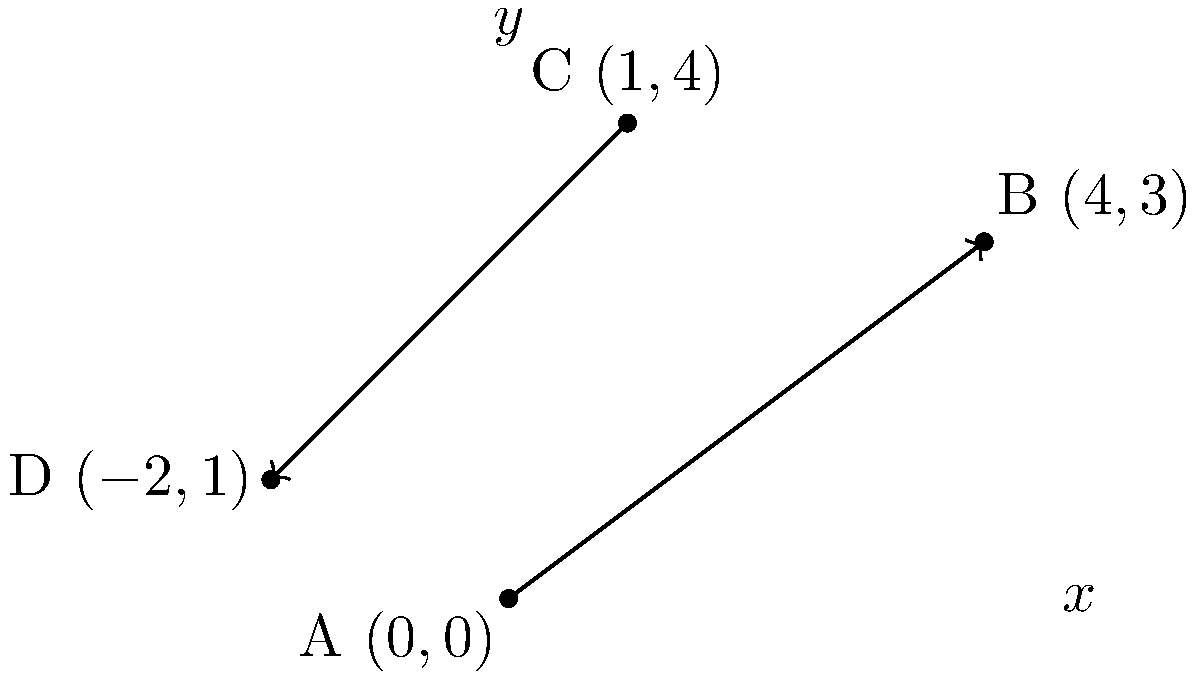In the coordinate plane shown above, two lines intersect. Line 1 passes through points A(0,0) and B(4,3), while Line 2 passes through points C(1,4) and D(-2,1). What is the measure of the acute angle formed by the intersection of these two lines, rounded to the nearest degree? To find the angle between two intersecting lines, we can follow these steps:

1. Calculate the slopes of both lines:

   For Line 1 (AB): $m_1 = \frac{y_B - y_A}{x_B - x_A} = \frac{3 - 0}{4 - 0} = \frac{3}{4}$

   For Line 2 (CD): $m_2 = \frac{y_C - y_D}{x_C - x_D} = \frac{4 - 1}{1 - (-2)} = \frac{3}{3} = 1$

2. Use the formula for the angle between two lines:
   $$\tan \theta = \left|\frac{m_2 - m_1}{1 + m_1m_2}\right|$$

3. Substitute the slopes into the formula:
   $$\tan \theta = \left|\frac{1 - \frac{3}{4}}{1 + \frac{3}{4} \cdot 1}\right| = \left|\frac{\frac{1}{4}}{\frac{7}{4}}\right| = \frac{1}{7}$$

4. Take the inverse tangent (arctan) of both sides:
   $$\theta = \arctan\left(\frac{1}{7}\right)$$

5. Calculate the result and round to the nearest degree:
   $$\theta \approx 8.13^\circ \approx 8^\circ$$

Therefore, the acute angle formed by the intersection of these two lines is approximately 8°.
Answer: 8° 